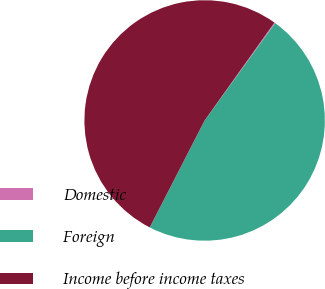Convert chart to OTSL. <chart><loc_0><loc_0><loc_500><loc_500><pie_chart><fcel>Domestic<fcel>Foreign<fcel>Income before income taxes<nl><fcel>0.13%<fcel>47.56%<fcel>52.31%<nl></chart> 